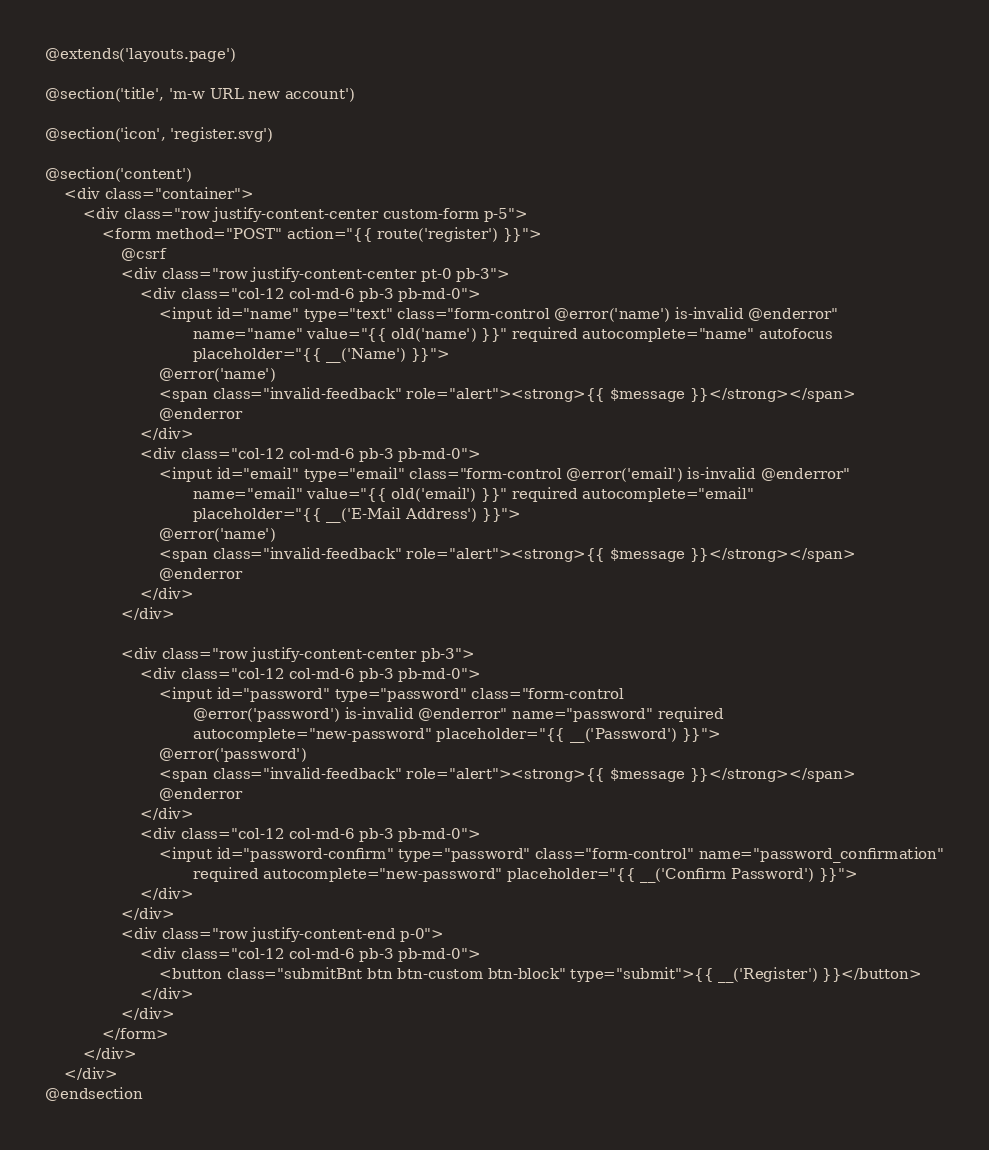<code> <loc_0><loc_0><loc_500><loc_500><_PHP_>@extends('layouts.page')

@section('title', 'm-w URL new account')

@section('icon', 'register.svg')

@section('content')
    <div class="container">
        <div class="row justify-content-center custom-form p-5">
            <form method="POST" action="{{ route('register') }}">
                @csrf
                <div class="row justify-content-center pt-0 pb-3">
                    <div class="col-12 col-md-6 pb-3 pb-md-0">
                        <input id="name" type="text" class="form-control @error('name') is-invalid @enderror"
                               name="name" value="{{ old('name') }}" required autocomplete="name" autofocus
                               placeholder="{{ __('Name') }}">
                        @error('name')
                        <span class="invalid-feedback" role="alert"><strong>{{ $message }}</strong></span>
                        @enderror
                    </div>
                    <div class="col-12 col-md-6 pb-3 pb-md-0">
                        <input id="email" type="email" class="form-control @error('email') is-invalid @enderror"
                               name="email" value="{{ old('email') }}" required autocomplete="email"
                               placeholder="{{ __('E-Mail Address') }}">
                        @error('name')
                        <span class="invalid-feedback" role="alert"><strong>{{ $message }}</strong></span>
                        @enderror
                    </div>
                </div>

                <div class="row justify-content-center pb-3">
                    <div class="col-12 col-md-6 pb-3 pb-md-0">
                        <input id="password" type="password" class="form-control
                               @error('password') is-invalid @enderror" name="password" required
                               autocomplete="new-password" placeholder="{{ __('Password') }}">
                        @error('password')
                        <span class="invalid-feedback" role="alert"><strong>{{ $message }}</strong></span>
                        @enderror
                    </div>
                    <div class="col-12 col-md-6 pb-3 pb-md-0">
                        <input id="password-confirm" type="password" class="form-control" name="password_confirmation"
                               required autocomplete="new-password" placeholder="{{ __('Confirm Password') }}">
                    </div>
                </div>
                <div class="row justify-content-end p-0">
                    <div class="col-12 col-md-6 pb-3 pb-md-0">
                        <button class="submitBnt btn btn-custom btn-block" type="submit">{{ __('Register') }}</button>
                    </div>
                </div>
            </form>
        </div>
    </div>
@endsection
</code> 